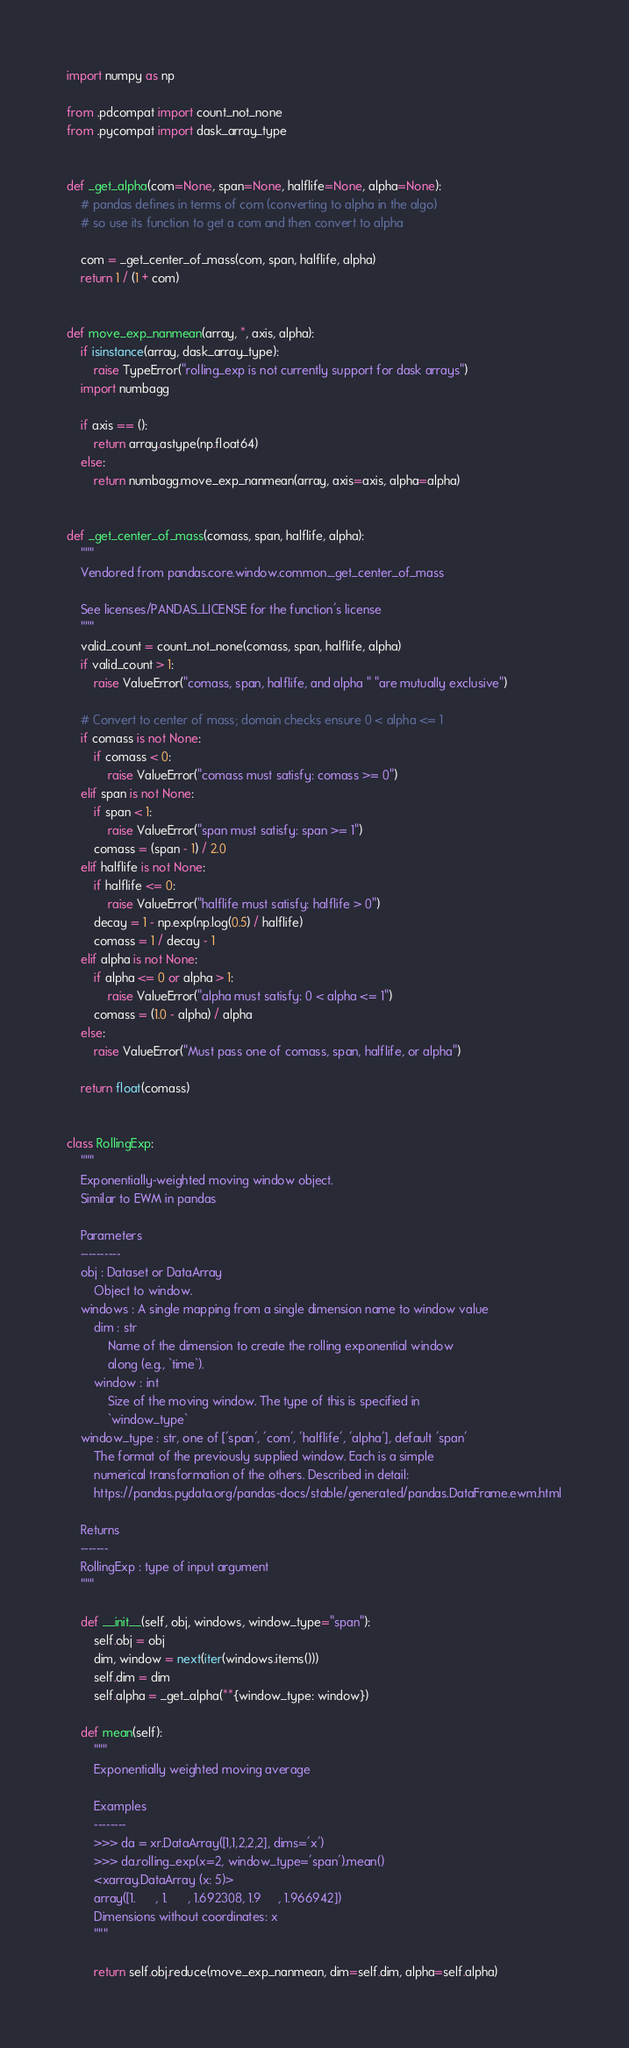Convert code to text. <code><loc_0><loc_0><loc_500><loc_500><_Python_>import numpy as np

from .pdcompat import count_not_none
from .pycompat import dask_array_type


def _get_alpha(com=None, span=None, halflife=None, alpha=None):
    # pandas defines in terms of com (converting to alpha in the algo)
    # so use its function to get a com and then convert to alpha

    com = _get_center_of_mass(com, span, halflife, alpha)
    return 1 / (1 + com)


def move_exp_nanmean(array, *, axis, alpha):
    if isinstance(array, dask_array_type):
        raise TypeError("rolling_exp is not currently support for dask arrays")
    import numbagg

    if axis == ():
        return array.astype(np.float64)
    else:
        return numbagg.move_exp_nanmean(array, axis=axis, alpha=alpha)


def _get_center_of_mass(comass, span, halflife, alpha):
    """
    Vendored from pandas.core.window.common._get_center_of_mass

    See licenses/PANDAS_LICENSE for the function's license
    """
    valid_count = count_not_none(comass, span, halflife, alpha)
    if valid_count > 1:
        raise ValueError("comass, span, halflife, and alpha " "are mutually exclusive")

    # Convert to center of mass; domain checks ensure 0 < alpha <= 1
    if comass is not None:
        if comass < 0:
            raise ValueError("comass must satisfy: comass >= 0")
    elif span is not None:
        if span < 1:
            raise ValueError("span must satisfy: span >= 1")
        comass = (span - 1) / 2.0
    elif halflife is not None:
        if halflife <= 0:
            raise ValueError("halflife must satisfy: halflife > 0")
        decay = 1 - np.exp(np.log(0.5) / halflife)
        comass = 1 / decay - 1
    elif alpha is not None:
        if alpha <= 0 or alpha > 1:
            raise ValueError("alpha must satisfy: 0 < alpha <= 1")
        comass = (1.0 - alpha) / alpha
    else:
        raise ValueError("Must pass one of comass, span, halflife, or alpha")

    return float(comass)


class RollingExp:
    """
    Exponentially-weighted moving window object.
    Similar to EWM in pandas

    Parameters
    ----------
    obj : Dataset or DataArray
        Object to window.
    windows : A single mapping from a single dimension name to window value
        dim : str
            Name of the dimension to create the rolling exponential window
            along (e.g., `time`).
        window : int
            Size of the moving window. The type of this is specified in
            `window_type`
    window_type : str, one of ['span', 'com', 'halflife', 'alpha'], default 'span'
        The format of the previously supplied window. Each is a simple
        numerical transformation of the others. Described in detail:
        https://pandas.pydata.org/pandas-docs/stable/generated/pandas.DataFrame.ewm.html

    Returns
    -------
    RollingExp : type of input argument
    """

    def __init__(self, obj, windows, window_type="span"):
        self.obj = obj
        dim, window = next(iter(windows.items()))
        self.dim = dim
        self.alpha = _get_alpha(**{window_type: window})

    def mean(self):
        """
        Exponentially weighted moving average

        Examples
        --------
        >>> da = xr.DataArray([1,1,2,2,2], dims='x')
        >>> da.rolling_exp(x=2, window_type='span').mean()
        <xarray.DataArray (x: 5)>
        array([1.      , 1.      , 1.692308, 1.9     , 1.966942])
        Dimensions without coordinates: x
        """

        return self.obj.reduce(move_exp_nanmean, dim=self.dim, alpha=self.alpha)
</code> 